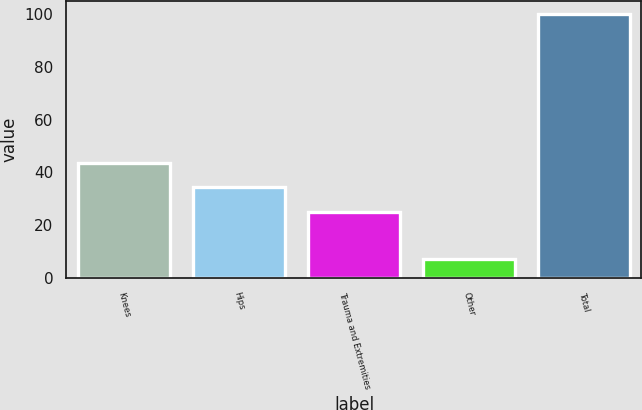Convert chart. <chart><loc_0><loc_0><loc_500><loc_500><bar_chart><fcel>Knees<fcel>Hips<fcel>Trauma and Extremities<fcel>Other<fcel>Total<nl><fcel>43.6<fcel>34.3<fcel>25<fcel>7<fcel>100<nl></chart> 